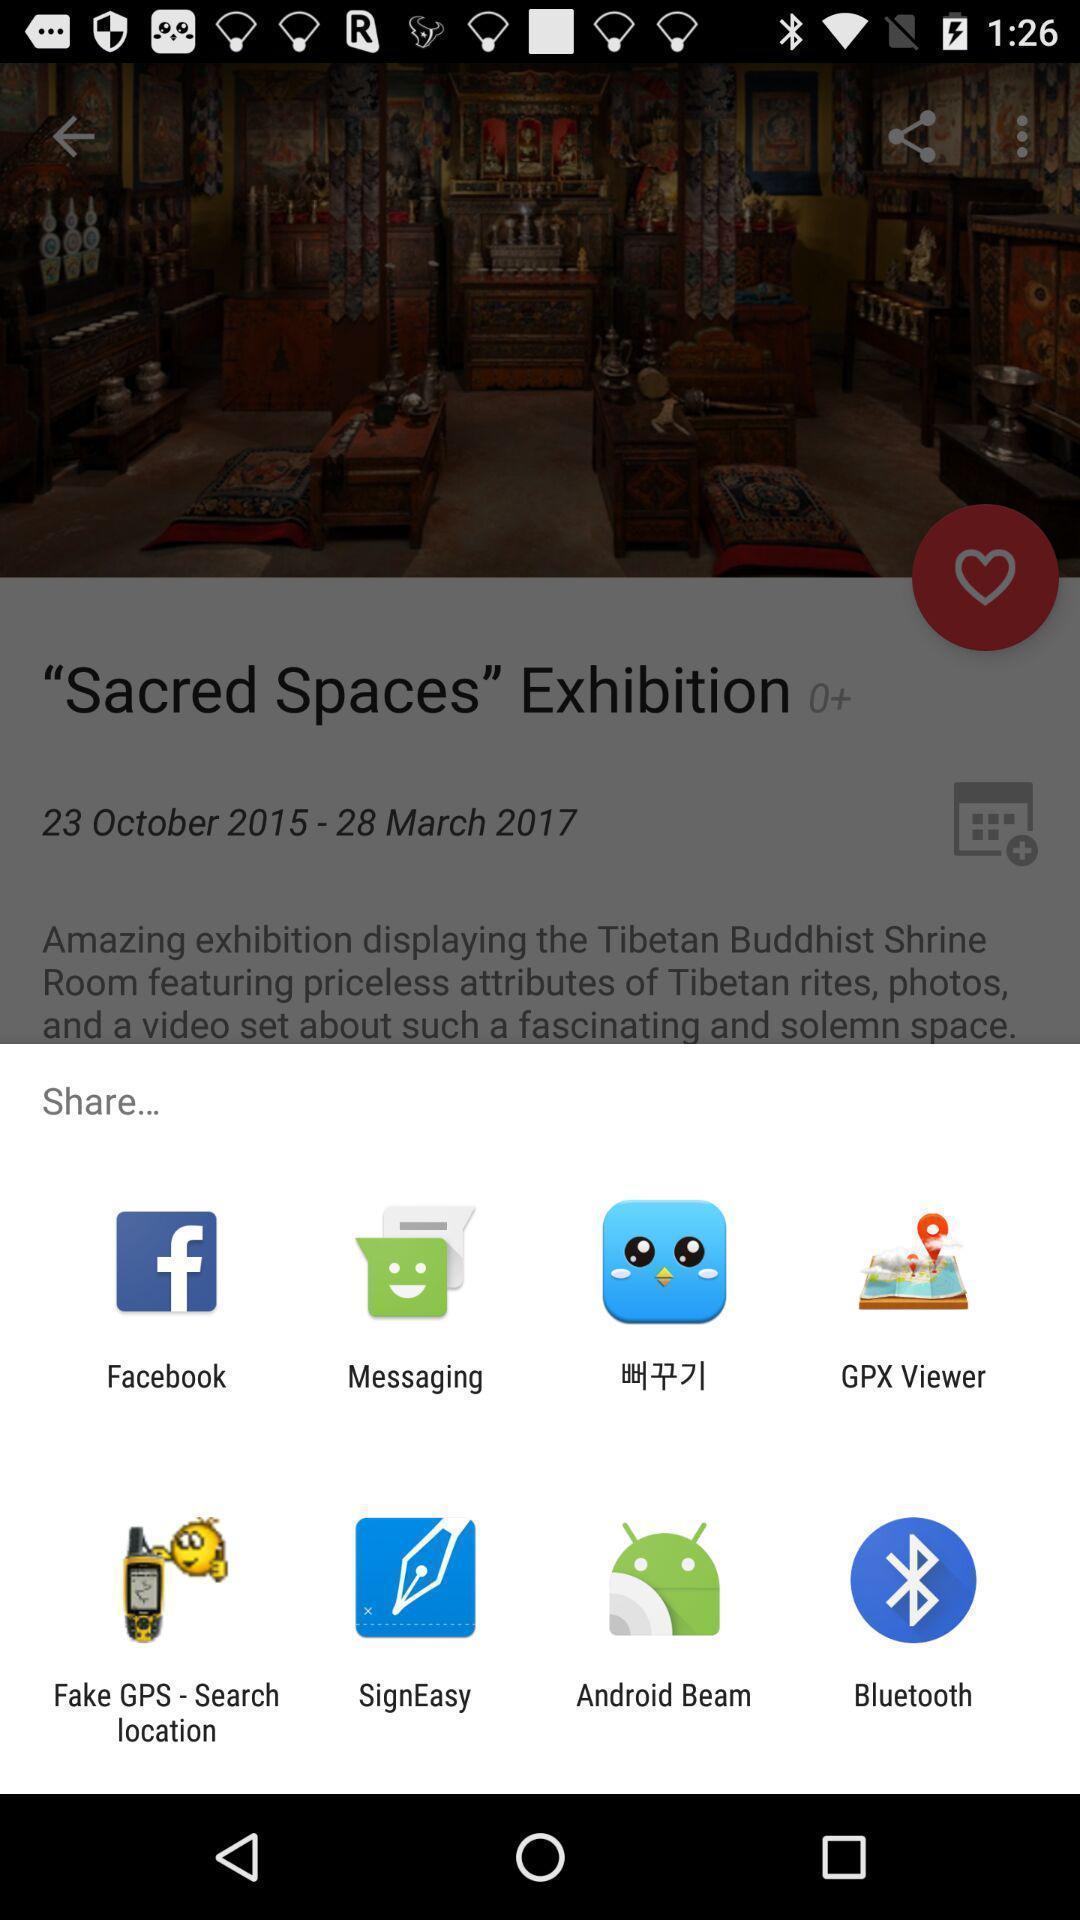Provide a textual representation of this image. Push up page showing app preference to share. 